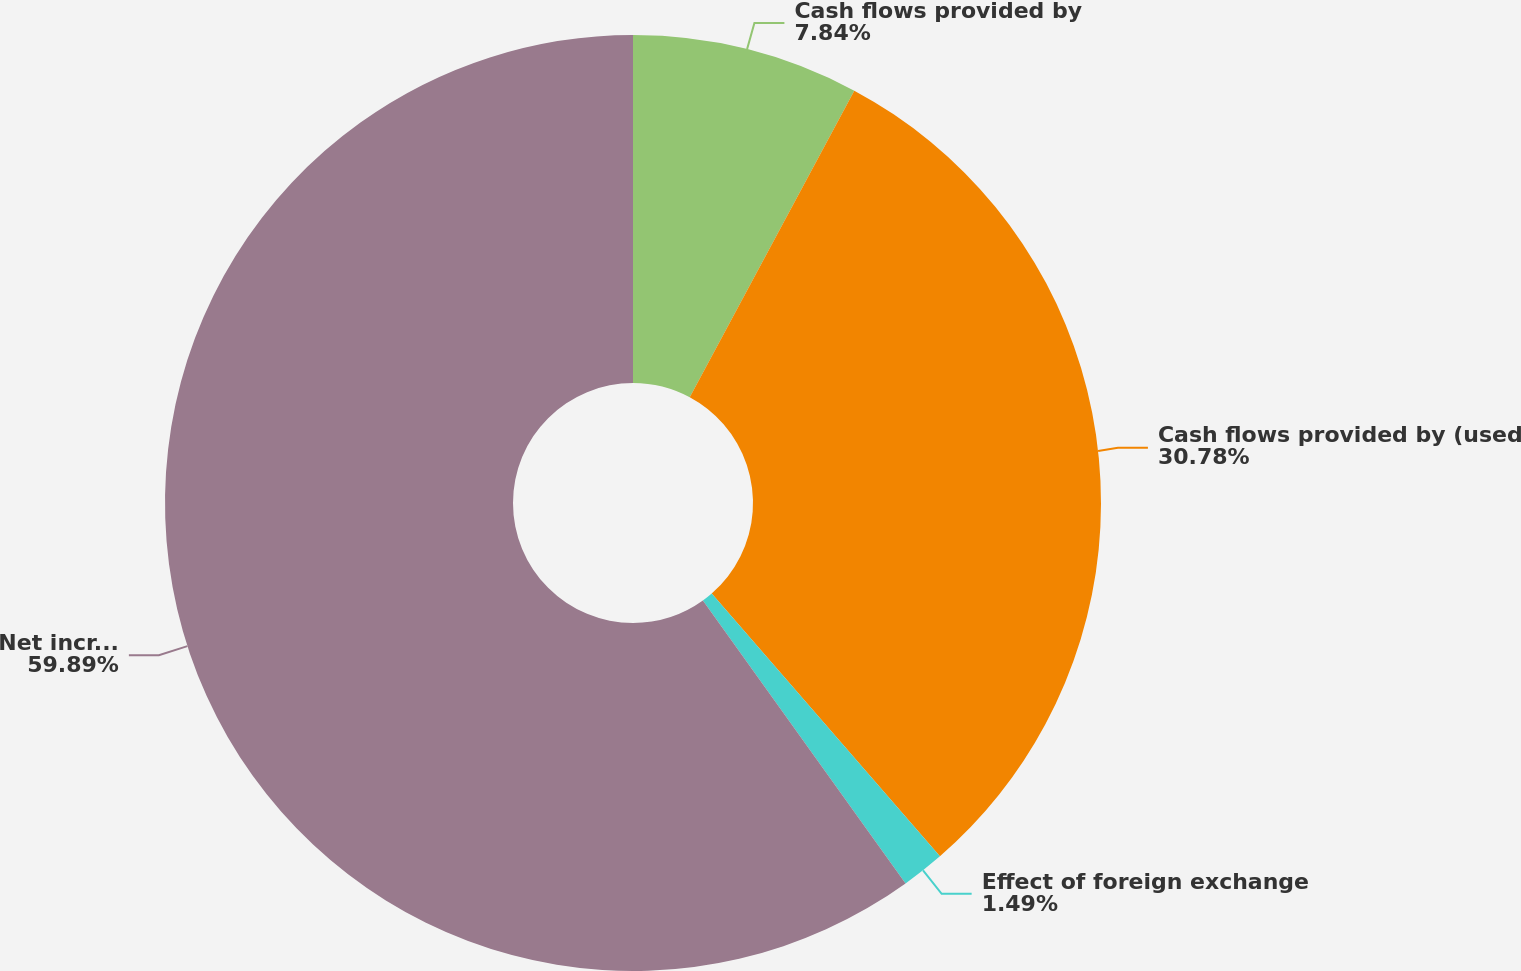Convert chart to OTSL. <chart><loc_0><loc_0><loc_500><loc_500><pie_chart><fcel>Cash flows provided by<fcel>Cash flows provided by (used<fcel>Effect of foreign exchange<fcel>Net increase (decrease) in<nl><fcel>7.84%<fcel>30.78%<fcel>1.49%<fcel>59.9%<nl></chart> 